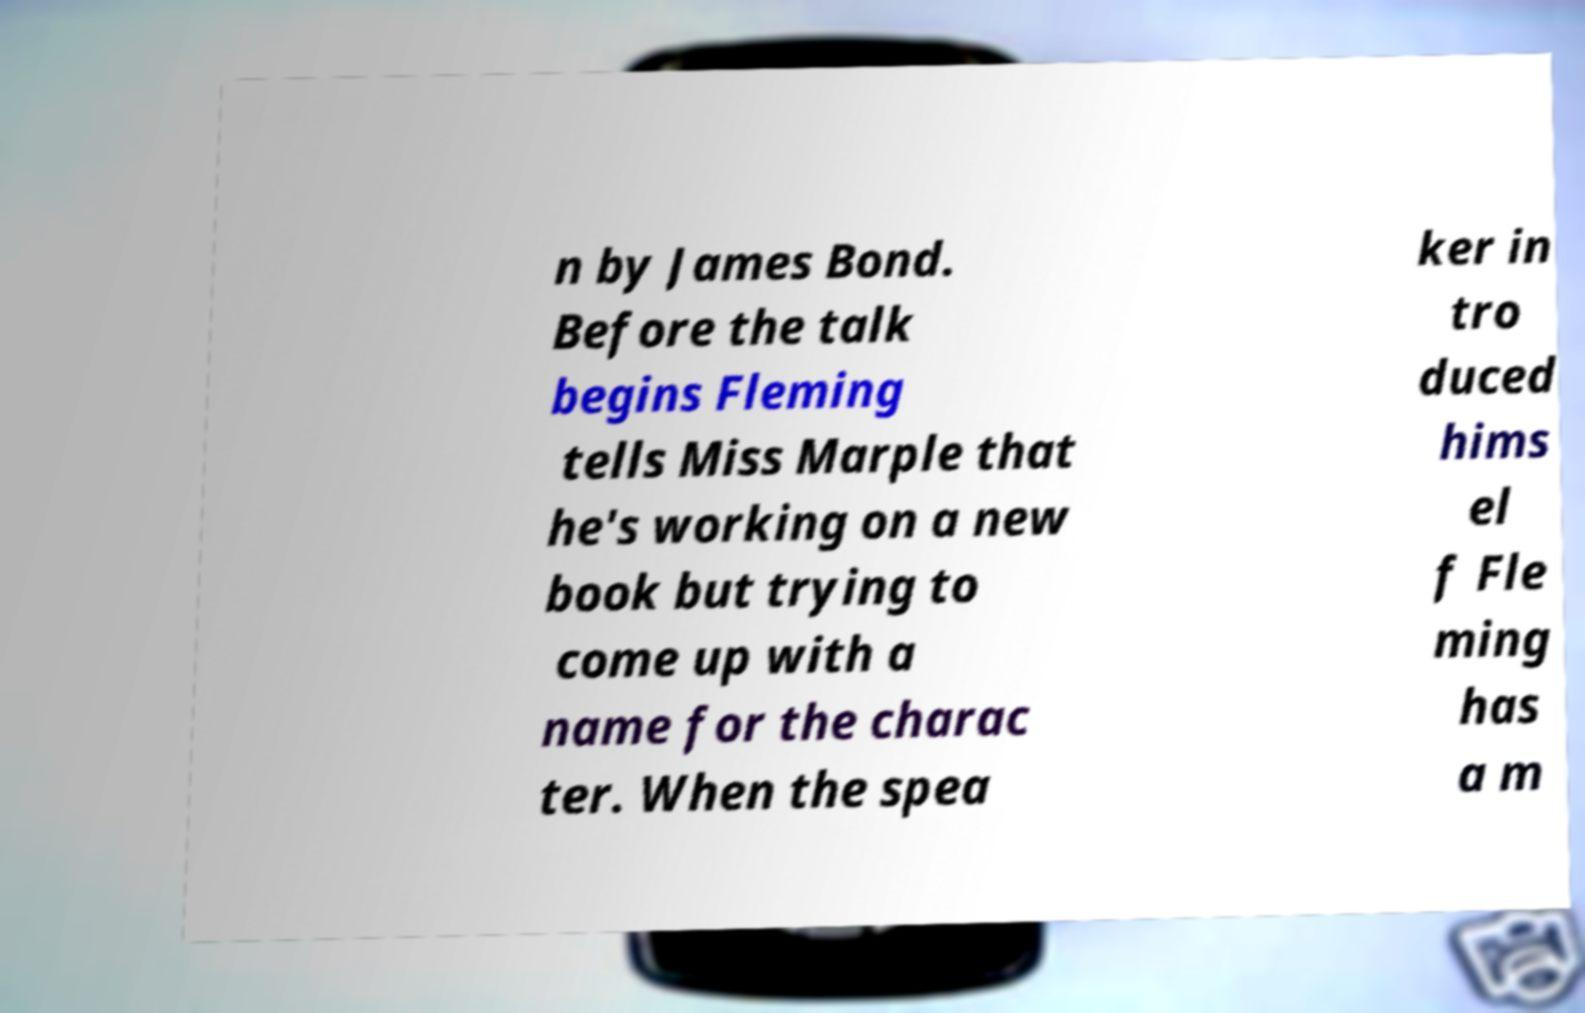Could you extract and type out the text from this image? n by James Bond. Before the talk begins Fleming tells Miss Marple that he's working on a new book but trying to come up with a name for the charac ter. When the spea ker in tro duced hims el f Fle ming has a m 